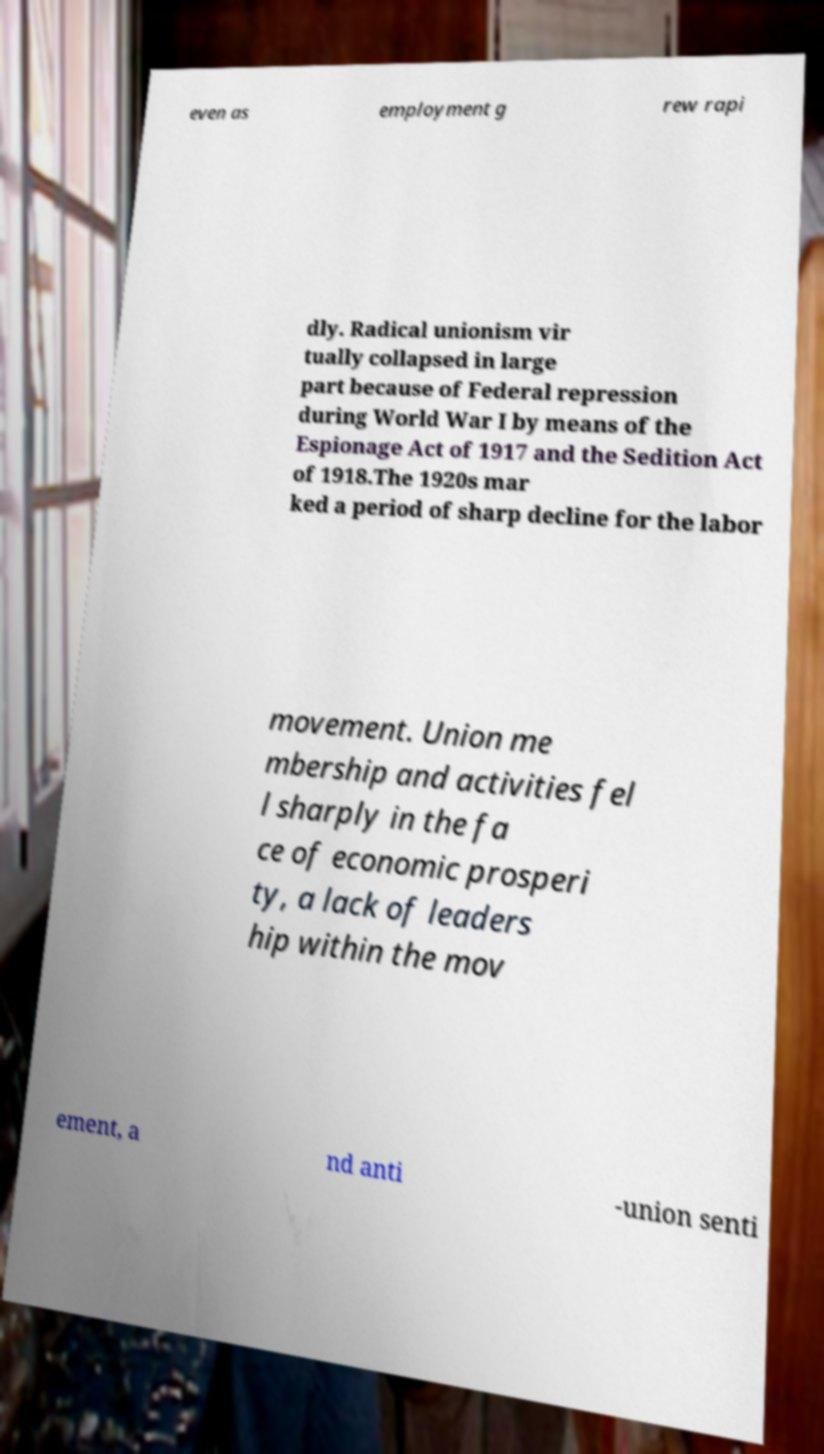Can you accurately transcribe the text from the provided image for me? even as employment g rew rapi dly. Radical unionism vir tually collapsed in large part because of Federal repression during World War I by means of the Espionage Act of 1917 and the Sedition Act of 1918.The 1920s mar ked a period of sharp decline for the labor movement. Union me mbership and activities fel l sharply in the fa ce of economic prosperi ty, a lack of leaders hip within the mov ement, a nd anti -union senti 